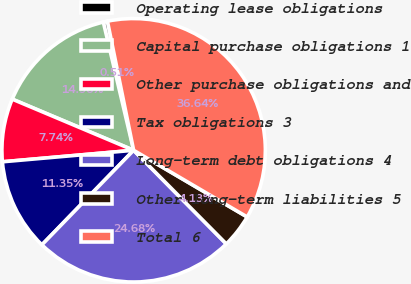Convert chart. <chart><loc_0><loc_0><loc_500><loc_500><pie_chart><fcel>Operating lease obligations<fcel>Capital purchase obligations 1<fcel>Other purchase obligations and<fcel>Tax obligations 3<fcel>Long-term debt obligations 4<fcel>Other long-term liabilities 5<fcel>Total 6<nl><fcel>0.51%<fcel>14.96%<fcel>7.74%<fcel>11.35%<fcel>24.68%<fcel>4.13%<fcel>36.64%<nl></chart> 